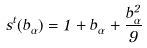<formula> <loc_0><loc_0><loc_500><loc_500>s ^ { t } ( b _ { \alpha } ) = 1 + b _ { \alpha } + \frac { b _ { \alpha } ^ { 2 } } { 9 }</formula> 